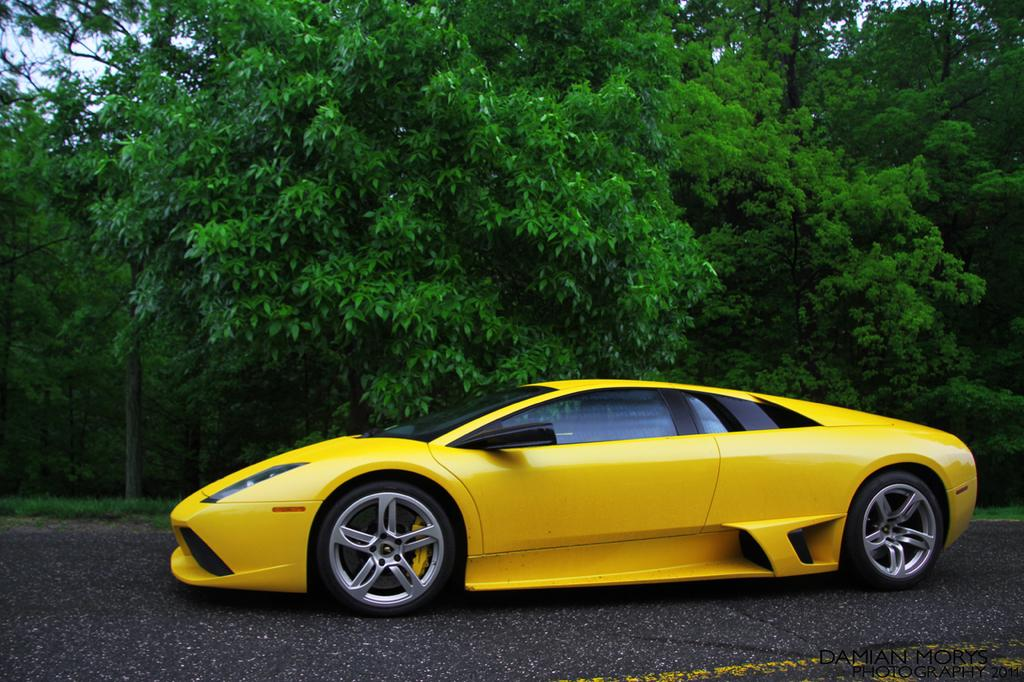What is the main subject of the image? There is a car in the image. What color is the car? The car is yellow. Where is the car located in the image? The car is on the road. What can be seen in the background of the image? There are trees and the sky visible in the background of the image. Can you see any arches or alleys in the image? There are no arches or alleys present in the image; it features a yellow car on the road with trees and the sky in the background. 